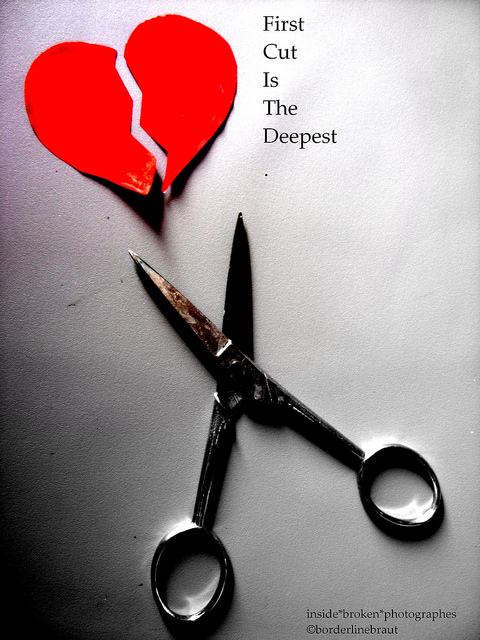Please transcribe the text information in this image. First Cut Is The Deepest inside broken photographes &#169;borderlinebraut 